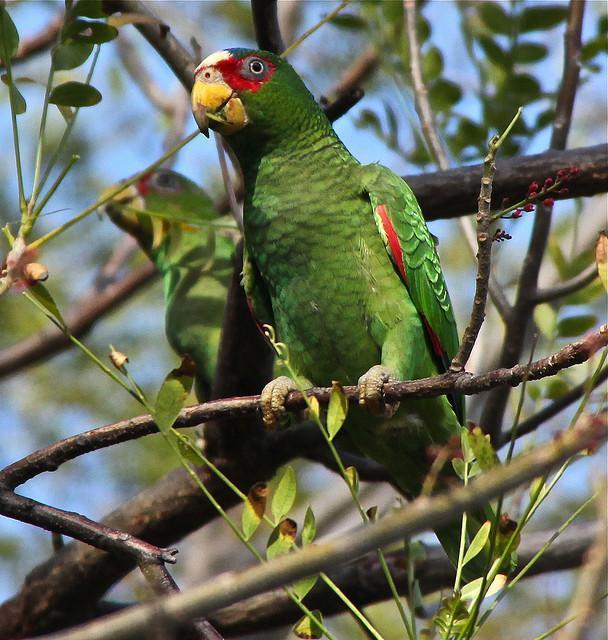How many birds are in the photo?
Give a very brief answer. 2. How many remotes can be seen?
Give a very brief answer. 0. 